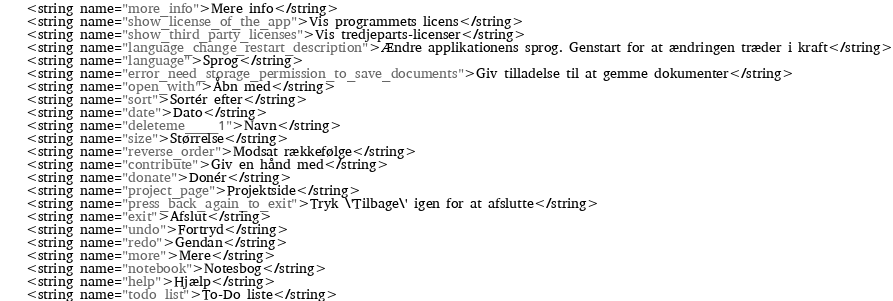Convert code to text. <code><loc_0><loc_0><loc_500><loc_500><_XML_>    <string name="more_info">Mere info</string>
    <string name="show_license_of_the_app">Vis programmets licens</string>
    <string name="show_third_party_licenses">Vis tredjeparts-licenser</string>
    <string name="language_change_restart_description">Ændre applikationens sprog. Genstart for at ændringen træder i kraft</string>
    <string name="language">Sprog</string>
    <string name="error_need_storage_permission_to_save_documents">Giv tilladelse til at gemme dokumenter</string>
    <string name="open_with">Åbn med</string>
    <string name="sort">Sortér efter</string>
    <string name="date">Dato</string>
    <string name="deleteme____1">Navn</string>
    <string name="size">Størrelse</string>
    <string name="reverse_order">Modsat rækkefølge</string>
    <string name="contribute">Giv en hånd med</string>
    <string name="donate">Donér</string>
    <string name="project_page">Projektside</string>
    <string name="press_back_again_to_exit">Tryk \'Tilbage\' igen for at afslutte</string>
    <string name="exit">Afslut</string>
    <string name="undo">Fortryd</string>
    <string name="redo">Gendan</string>
    <string name="more">Mere</string>
    <string name="notebook">Notesbog</string>
    <string name="help">Hjælp</string>
    <string name="todo_list">To-Do liste</string></code> 